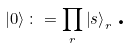<formula> <loc_0><loc_0><loc_500><loc_500>\left | 0 \right \rangle \colon = \prod _ { r } \left | s \right \rangle _ { r } \, \text {.}</formula> 